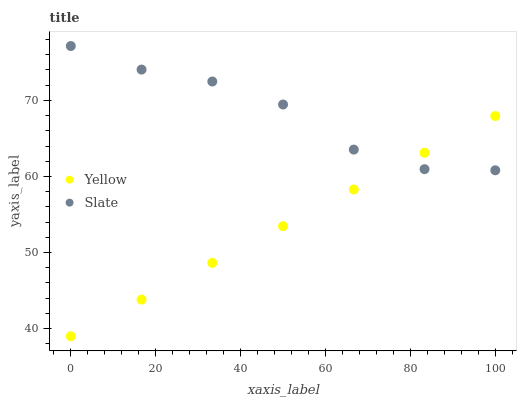Does Yellow have the minimum area under the curve?
Answer yes or no. Yes. Does Slate have the maximum area under the curve?
Answer yes or no. Yes. Does Yellow have the maximum area under the curve?
Answer yes or no. No. Is Yellow the smoothest?
Answer yes or no. Yes. Is Slate the roughest?
Answer yes or no. Yes. Is Yellow the roughest?
Answer yes or no. No. Does Yellow have the lowest value?
Answer yes or no. Yes. Does Slate have the highest value?
Answer yes or no. Yes. Does Yellow have the highest value?
Answer yes or no. No. Does Yellow intersect Slate?
Answer yes or no. Yes. Is Yellow less than Slate?
Answer yes or no. No. Is Yellow greater than Slate?
Answer yes or no. No. 